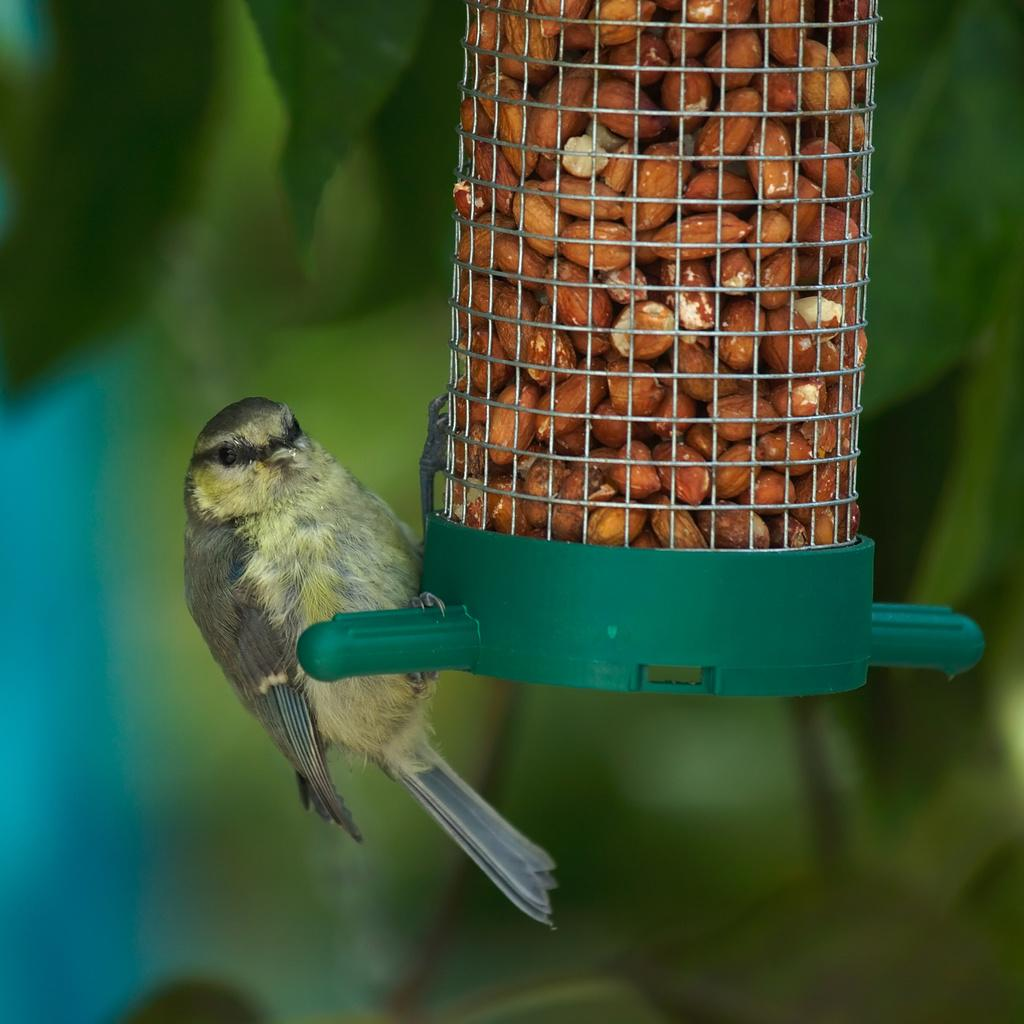What type of animal is in the image? There is a bird in the image. Can you describe the bird's appearance? The bird has brown and cream colors. What is inside the bird's cage? There is food in the bird's cage. What can be seen in the background of the image? The background of the image includes green leaves. How does the bird use the wheel to fly in the image? There is no wheel present in the image, and birds do not use wheels to fly. 